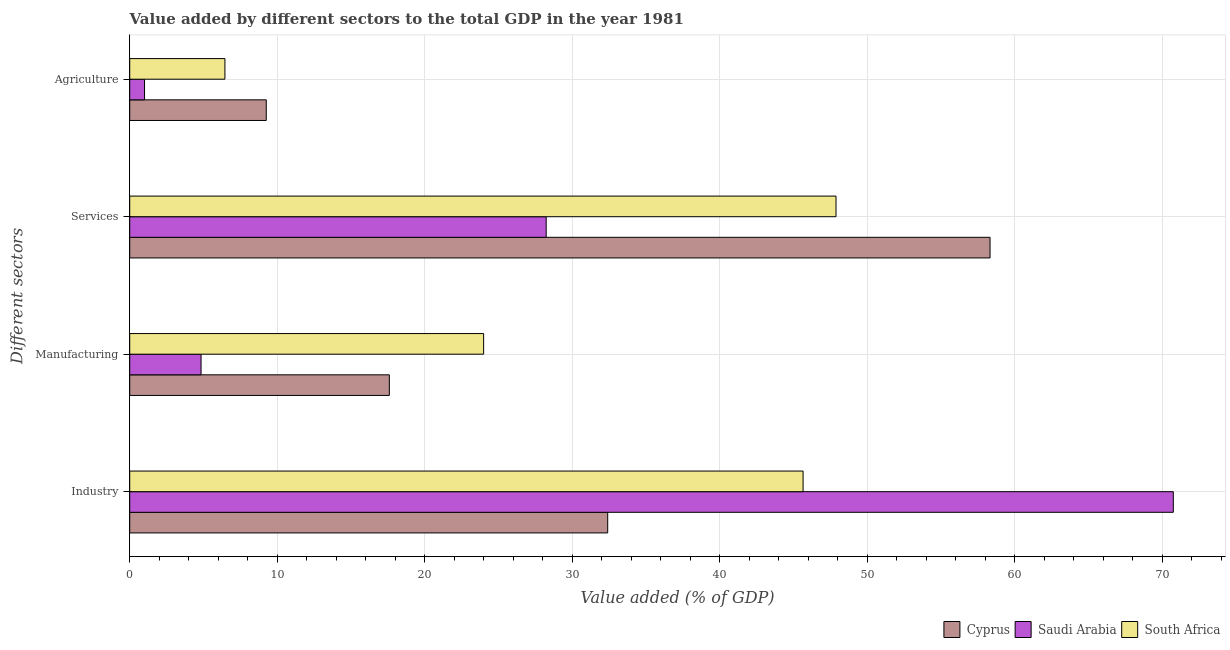How many groups of bars are there?
Your response must be concise. 4. How many bars are there on the 2nd tick from the top?
Offer a terse response. 3. What is the label of the 2nd group of bars from the top?
Make the answer very short. Services. What is the value added by agricultural sector in Cyprus?
Make the answer very short. 9.26. Across all countries, what is the maximum value added by agricultural sector?
Offer a very short reply. 9.26. Across all countries, what is the minimum value added by agricultural sector?
Keep it short and to the point. 1. In which country was the value added by services sector maximum?
Make the answer very short. Cyprus. In which country was the value added by manufacturing sector minimum?
Make the answer very short. Saudi Arabia. What is the total value added by manufacturing sector in the graph?
Offer a very short reply. 46.44. What is the difference between the value added by agricultural sector in South Africa and that in Saudi Arabia?
Your answer should be compact. 5.45. What is the difference between the value added by services sector in Saudi Arabia and the value added by industrial sector in Cyprus?
Make the answer very short. -4.17. What is the average value added by industrial sector per country?
Give a very brief answer. 49.61. What is the difference between the value added by agricultural sector and value added by services sector in Cyprus?
Make the answer very short. -49.08. In how many countries, is the value added by services sector greater than 56 %?
Your response must be concise. 1. What is the ratio of the value added by services sector in Saudi Arabia to that in South Africa?
Make the answer very short. 0.59. Is the difference between the value added by industrial sector in Saudi Arabia and Cyprus greater than the difference between the value added by agricultural sector in Saudi Arabia and Cyprus?
Provide a succinct answer. Yes. What is the difference between the highest and the second highest value added by manufacturing sector?
Offer a very short reply. 6.39. What is the difference between the highest and the lowest value added by services sector?
Ensure brevity in your answer.  30.1. Is the sum of the value added by agricultural sector in Cyprus and South Africa greater than the maximum value added by industrial sector across all countries?
Keep it short and to the point. No. Is it the case that in every country, the sum of the value added by industrial sector and value added by manufacturing sector is greater than the sum of value added by agricultural sector and value added by services sector?
Ensure brevity in your answer.  Yes. What does the 1st bar from the top in Industry represents?
Offer a terse response. South Africa. What does the 2nd bar from the bottom in Manufacturing represents?
Offer a terse response. Saudi Arabia. Are all the bars in the graph horizontal?
Your answer should be compact. Yes. Are the values on the major ticks of X-axis written in scientific E-notation?
Provide a succinct answer. No. Does the graph contain any zero values?
Offer a very short reply. No. Does the graph contain grids?
Keep it short and to the point. Yes. Where does the legend appear in the graph?
Make the answer very short. Bottom right. How many legend labels are there?
Give a very brief answer. 3. What is the title of the graph?
Make the answer very short. Value added by different sectors to the total GDP in the year 1981. What is the label or title of the X-axis?
Offer a terse response. Value added (% of GDP). What is the label or title of the Y-axis?
Make the answer very short. Different sectors. What is the Value added (% of GDP) of Cyprus in Industry?
Your answer should be compact. 32.41. What is the Value added (% of GDP) in Saudi Arabia in Industry?
Give a very brief answer. 70.76. What is the Value added (% of GDP) in South Africa in Industry?
Your response must be concise. 45.66. What is the Value added (% of GDP) of Cyprus in Manufacturing?
Give a very brief answer. 17.6. What is the Value added (% of GDP) in Saudi Arabia in Manufacturing?
Make the answer very short. 4.84. What is the Value added (% of GDP) of South Africa in Manufacturing?
Your answer should be very brief. 24. What is the Value added (% of GDP) of Cyprus in Services?
Keep it short and to the point. 58.33. What is the Value added (% of GDP) in Saudi Arabia in Services?
Offer a terse response. 28.24. What is the Value added (% of GDP) in South Africa in Services?
Offer a terse response. 47.89. What is the Value added (% of GDP) in Cyprus in Agriculture?
Give a very brief answer. 9.26. What is the Value added (% of GDP) in Saudi Arabia in Agriculture?
Give a very brief answer. 1. What is the Value added (% of GDP) in South Africa in Agriculture?
Offer a terse response. 6.45. Across all Different sectors, what is the maximum Value added (% of GDP) of Cyprus?
Ensure brevity in your answer.  58.33. Across all Different sectors, what is the maximum Value added (% of GDP) of Saudi Arabia?
Offer a very short reply. 70.76. Across all Different sectors, what is the maximum Value added (% of GDP) in South Africa?
Your answer should be compact. 47.89. Across all Different sectors, what is the minimum Value added (% of GDP) in Cyprus?
Ensure brevity in your answer.  9.26. Across all Different sectors, what is the minimum Value added (% of GDP) of Saudi Arabia?
Provide a succinct answer. 1. Across all Different sectors, what is the minimum Value added (% of GDP) in South Africa?
Your response must be concise. 6.45. What is the total Value added (% of GDP) in Cyprus in the graph?
Your answer should be very brief. 117.6. What is the total Value added (% of GDP) in Saudi Arabia in the graph?
Offer a terse response. 104.84. What is the total Value added (% of GDP) of South Africa in the graph?
Ensure brevity in your answer.  124. What is the difference between the Value added (% of GDP) of Cyprus in Industry and that in Manufacturing?
Give a very brief answer. 14.81. What is the difference between the Value added (% of GDP) in Saudi Arabia in Industry and that in Manufacturing?
Give a very brief answer. 65.92. What is the difference between the Value added (% of GDP) in South Africa in Industry and that in Manufacturing?
Your response must be concise. 21.66. What is the difference between the Value added (% of GDP) of Cyprus in Industry and that in Services?
Provide a short and direct response. -25.92. What is the difference between the Value added (% of GDP) in Saudi Arabia in Industry and that in Services?
Keep it short and to the point. 42.52. What is the difference between the Value added (% of GDP) in South Africa in Industry and that in Services?
Offer a very short reply. -2.23. What is the difference between the Value added (% of GDP) in Cyprus in Industry and that in Agriculture?
Offer a very short reply. 23.15. What is the difference between the Value added (% of GDP) in Saudi Arabia in Industry and that in Agriculture?
Provide a succinct answer. 69.76. What is the difference between the Value added (% of GDP) in South Africa in Industry and that in Agriculture?
Keep it short and to the point. 39.2. What is the difference between the Value added (% of GDP) of Cyprus in Manufacturing and that in Services?
Your answer should be compact. -40.73. What is the difference between the Value added (% of GDP) in Saudi Arabia in Manufacturing and that in Services?
Your answer should be very brief. -23.4. What is the difference between the Value added (% of GDP) of South Africa in Manufacturing and that in Services?
Give a very brief answer. -23.89. What is the difference between the Value added (% of GDP) of Cyprus in Manufacturing and that in Agriculture?
Ensure brevity in your answer.  8.34. What is the difference between the Value added (% of GDP) in Saudi Arabia in Manufacturing and that in Agriculture?
Your answer should be very brief. 3.83. What is the difference between the Value added (% of GDP) of South Africa in Manufacturing and that in Agriculture?
Keep it short and to the point. 17.54. What is the difference between the Value added (% of GDP) in Cyprus in Services and that in Agriculture?
Give a very brief answer. 49.08. What is the difference between the Value added (% of GDP) of Saudi Arabia in Services and that in Agriculture?
Provide a succinct answer. 27.23. What is the difference between the Value added (% of GDP) of South Africa in Services and that in Agriculture?
Your response must be concise. 41.43. What is the difference between the Value added (% of GDP) in Cyprus in Industry and the Value added (% of GDP) in Saudi Arabia in Manufacturing?
Ensure brevity in your answer.  27.57. What is the difference between the Value added (% of GDP) of Cyprus in Industry and the Value added (% of GDP) of South Africa in Manufacturing?
Ensure brevity in your answer.  8.41. What is the difference between the Value added (% of GDP) of Saudi Arabia in Industry and the Value added (% of GDP) of South Africa in Manufacturing?
Give a very brief answer. 46.76. What is the difference between the Value added (% of GDP) of Cyprus in Industry and the Value added (% of GDP) of Saudi Arabia in Services?
Provide a succinct answer. 4.17. What is the difference between the Value added (% of GDP) of Cyprus in Industry and the Value added (% of GDP) of South Africa in Services?
Offer a terse response. -15.48. What is the difference between the Value added (% of GDP) in Saudi Arabia in Industry and the Value added (% of GDP) in South Africa in Services?
Your answer should be compact. 22.87. What is the difference between the Value added (% of GDP) of Cyprus in Industry and the Value added (% of GDP) of Saudi Arabia in Agriculture?
Your answer should be compact. 31.41. What is the difference between the Value added (% of GDP) of Cyprus in Industry and the Value added (% of GDP) of South Africa in Agriculture?
Offer a very short reply. 25.95. What is the difference between the Value added (% of GDP) in Saudi Arabia in Industry and the Value added (% of GDP) in South Africa in Agriculture?
Ensure brevity in your answer.  64.3. What is the difference between the Value added (% of GDP) in Cyprus in Manufacturing and the Value added (% of GDP) in Saudi Arabia in Services?
Ensure brevity in your answer.  -10.63. What is the difference between the Value added (% of GDP) in Cyprus in Manufacturing and the Value added (% of GDP) in South Africa in Services?
Offer a very short reply. -30.29. What is the difference between the Value added (% of GDP) in Saudi Arabia in Manufacturing and the Value added (% of GDP) in South Africa in Services?
Your answer should be compact. -43.05. What is the difference between the Value added (% of GDP) of Cyprus in Manufacturing and the Value added (% of GDP) of Saudi Arabia in Agriculture?
Offer a terse response. 16.6. What is the difference between the Value added (% of GDP) of Cyprus in Manufacturing and the Value added (% of GDP) of South Africa in Agriculture?
Provide a succinct answer. 11.15. What is the difference between the Value added (% of GDP) in Saudi Arabia in Manufacturing and the Value added (% of GDP) in South Africa in Agriculture?
Keep it short and to the point. -1.62. What is the difference between the Value added (% of GDP) in Cyprus in Services and the Value added (% of GDP) in Saudi Arabia in Agriculture?
Provide a succinct answer. 57.33. What is the difference between the Value added (% of GDP) in Cyprus in Services and the Value added (% of GDP) in South Africa in Agriculture?
Provide a short and direct response. 51.88. What is the difference between the Value added (% of GDP) in Saudi Arabia in Services and the Value added (% of GDP) in South Africa in Agriculture?
Make the answer very short. 21.78. What is the average Value added (% of GDP) in Cyprus per Different sectors?
Your response must be concise. 29.4. What is the average Value added (% of GDP) in Saudi Arabia per Different sectors?
Make the answer very short. 26.21. What is the average Value added (% of GDP) in South Africa per Different sectors?
Offer a very short reply. 31. What is the difference between the Value added (% of GDP) of Cyprus and Value added (% of GDP) of Saudi Arabia in Industry?
Your answer should be compact. -38.35. What is the difference between the Value added (% of GDP) of Cyprus and Value added (% of GDP) of South Africa in Industry?
Provide a short and direct response. -13.25. What is the difference between the Value added (% of GDP) in Saudi Arabia and Value added (% of GDP) in South Africa in Industry?
Provide a succinct answer. 25.1. What is the difference between the Value added (% of GDP) in Cyprus and Value added (% of GDP) in Saudi Arabia in Manufacturing?
Ensure brevity in your answer.  12.77. What is the difference between the Value added (% of GDP) of Cyprus and Value added (% of GDP) of South Africa in Manufacturing?
Offer a terse response. -6.39. What is the difference between the Value added (% of GDP) of Saudi Arabia and Value added (% of GDP) of South Africa in Manufacturing?
Provide a succinct answer. -19.16. What is the difference between the Value added (% of GDP) in Cyprus and Value added (% of GDP) in Saudi Arabia in Services?
Provide a short and direct response. 30.1. What is the difference between the Value added (% of GDP) of Cyprus and Value added (% of GDP) of South Africa in Services?
Provide a short and direct response. 10.44. What is the difference between the Value added (% of GDP) of Saudi Arabia and Value added (% of GDP) of South Africa in Services?
Ensure brevity in your answer.  -19.65. What is the difference between the Value added (% of GDP) in Cyprus and Value added (% of GDP) in Saudi Arabia in Agriculture?
Keep it short and to the point. 8.25. What is the difference between the Value added (% of GDP) of Cyprus and Value added (% of GDP) of South Africa in Agriculture?
Ensure brevity in your answer.  2.8. What is the difference between the Value added (% of GDP) in Saudi Arabia and Value added (% of GDP) in South Africa in Agriculture?
Provide a succinct answer. -5.45. What is the ratio of the Value added (% of GDP) of Cyprus in Industry to that in Manufacturing?
Give a very brief answer. 1.84. What is the ratio of the Value added (% of GDP) in Saudi Arabia in Industry to that in Manufacturing?
Offer a terse response. 14.63. What is the ratio of the Value added (% of GDP) in South Africa in Industry to that in Manufacturing?
Ensure brevity in your answer.  1.9. What is the ratio of the Value added (% of GDP) in Cyprus in Industry to that in Services?
Offer a terse response. 0.56. What is the ratio of the Value added (% of GDP) in Saudi Arabia in Industry to that in Services?
Give a very brief answer. 2.51. What is the ratio of the Value added (% of GDP) of South Africa in Industry to that in Services?
Your response must be concise. 0.95. What is the ratio of the Value added (% of GDP) of Cyprus in Industry to that in Agriculture?
Make the answer very short. 3.5. What is the ratio of the Value added (% of GDP) in Saudi Arabia in Industry to that in Agriculture?
Ensure brevity in your answer.  70.52. What is the ratio of the Value added (% of GDP) in South Africa in Industry to that in Agriculture?
Keep it short and to the point. 7.07. What is the ratio of the Value added (% of GDP) of Cyprus in Manufacturing to that in Services?
Keep it short and to the point. 0.3. What is the ratio of the Value added (% of GDP) of Saudi Arabia in Manufacturing to that in Services?
Your response must be concise. 0.17. What is the ratio of the Value added (% of GDP) of South Africa in Manufacturing to that in Services?
Give a very brief answer. 0.5. What is the ratio of the Value added (% of GDP) in Cyprus in Manufacturing to that in Agriculture?
Provide a short and direct response. 1.9. What is the ratio of the Value added (% of GDP) in Saudi Arabia in Manufacturing to that in Agriculture?
Keep it short and to the point. 4.82. What is the ratio of the Value added (% of GDP) of South Africa in Manufacturing to that in Agriculture?
Ensure brevity in your answer.  3.72. What is the ratio of the Value added (% of GDP) of Cyprus in Services to that in Agriculture?
Ensure brevity in your answer.  6.3. What is the ratio of the Value added (% of GDP) in Saudi Arabia in Services to that in Agriculture?
Offer a very short reply. 28.14. What is the ratio of the Value added (% of GDP) of South Africa in Services to that in Agriculture?
Offer a very short reply. 7.42. What is the difference between the highest and the second highest Value added (% of GDP) in Cyprus?
Your response must be concise. 25.92. What is the difference between the highest and the second highest Value added (% of GDP) of Saudi Arabia?
Your response must be concise. 42.52. What is the difference between the highest and the second highest Value added (% of GDP) in South Africa?
Offer a terse response. 2.23. What is the difference between the highest and the lowest Value added (% of GDP) in Cyprus?
Keep it short and to the point. 49.08. What is the difference between the highest and the lowest Value added (% of GDP) of Saudi Arabia?
Keep it short and to the point. 69.76. What is the difference between the highest and the lowest Value added (% of GDP) of South Africa?
Give a very brief answer. 41.43. 